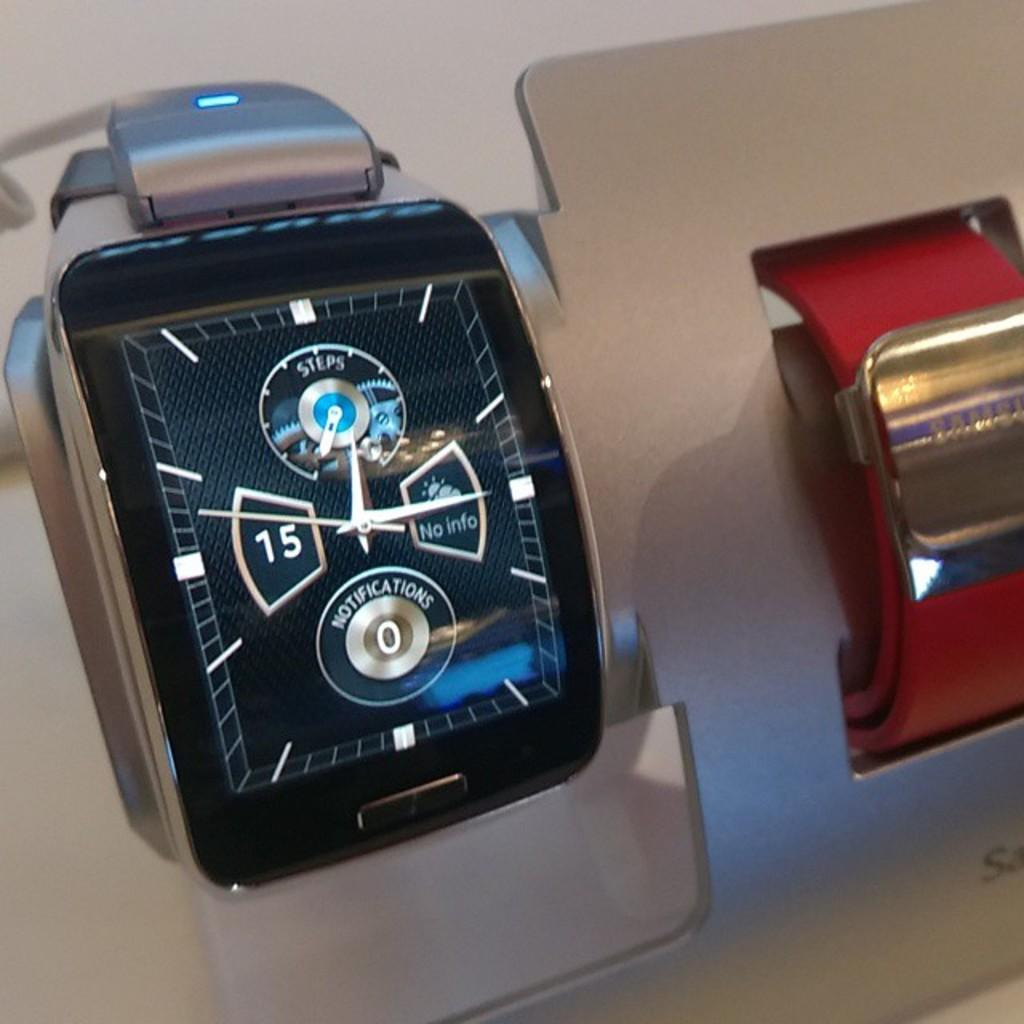<image>
Offer a succinct explanation of the picture presented. A watch currently has no weather info and has zero notifications. 